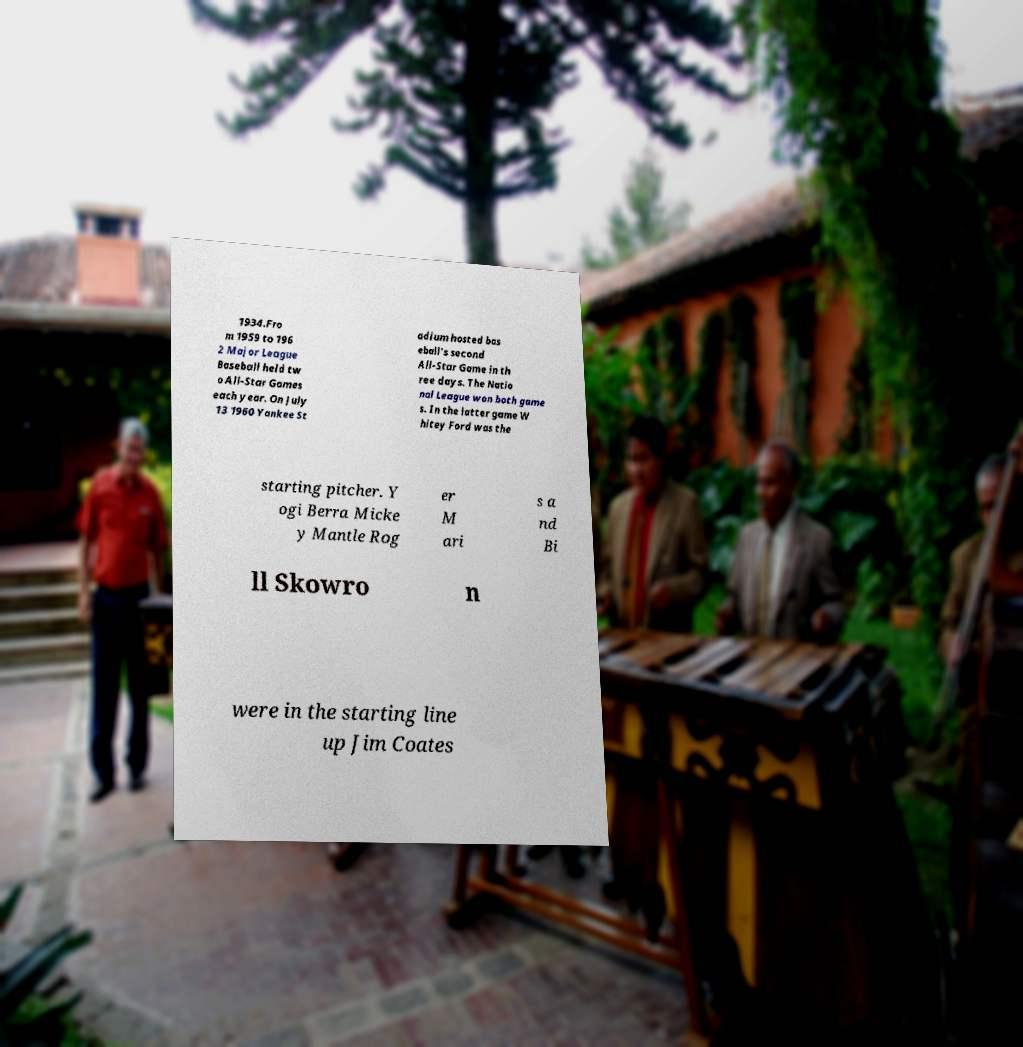Can you accurately transcribe the text from the provided image for me? 1934.Fro m 1959 to 196 2 Major League Baseball held tw o All-Star Games each year. On July 13 1960 Yankee St adium hosted bas eball's second All-Star Game in th ree days. The Natio nal League won both game s. In the latter game W hitey Ford was the starting pitcher. Y ogi Berra Micke y Mantle Rog er M ari s a nd Bi ll Skowro n were in the starting line up Jim Coates 